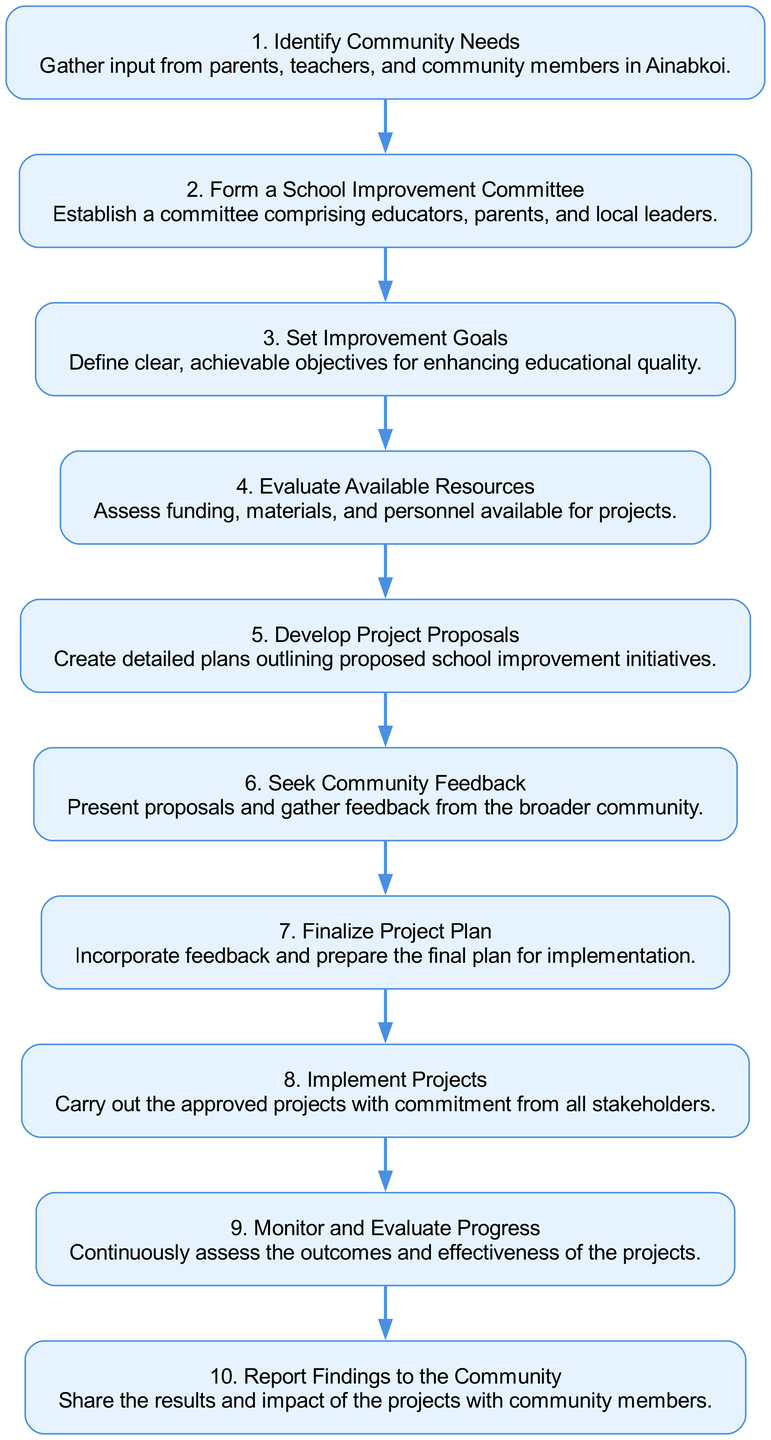What is the first step in the decision-making process? The first step, as indicated in the diagram, is "Identify Community Needs". This is shown at the top of the flow chart as the initial action required.
Answer: Identify Community Needs How many total steps are there in the process? By counting the nodes in the diagram, there are a total of ten steps. Each step represents a unique phase in the decision-making process, as laid out in the flow chart.
Answer: Ten What is the main objective of the second step? The second step, "Form a School Improvement Committee," aims to establish a group that includes educators, parents, and local leaders. This can be found beneath the first step in the diagram.
Answer: Establish a committee Which step follows the "Develop Project Proposals"? According to the diagram, "Seek Community Feedback" follows the "Develop Project Proposals," indicating that community input is sought after proposals are created. This is illustrated by the directed edge connecting these two steps.
Answer: Seek Community Feedback What does the last step of the process involve? The last step, "Report Findings to the Community," involves sharing the results and impact of the projects with community members, completing the feedback loop. This is visually represented as the end of the flow in the diagram.
Answer: Share results What is assessed in step four? In step four, "Evaluate Available Resources," the process involves assessing funding, materials, and personnel available for projects. This information is provided in the descriptive text associated with this step in the diagram.
Answer: Funding, materials, and personnel What is the relationship between "Set Improvement Goals" and "Finalize Project Plan"? The relationship is sequential where "Set Improvement Goals" must be accomplished before moving on to "Finalize Project Plan." This flow indicates that goals need to be defined before the project plan can be finalized, as shown by the directed edge between these two steps.
Answer: Sequential relationship How does the community engage after proposals are developed? After the development of proposals, the community engages by providing feedback during the "Seek Community Feedback" step. This directly follows the proposals in the flow chart, highlighting the participatory nature of the process.
Answer: Provide feedback 